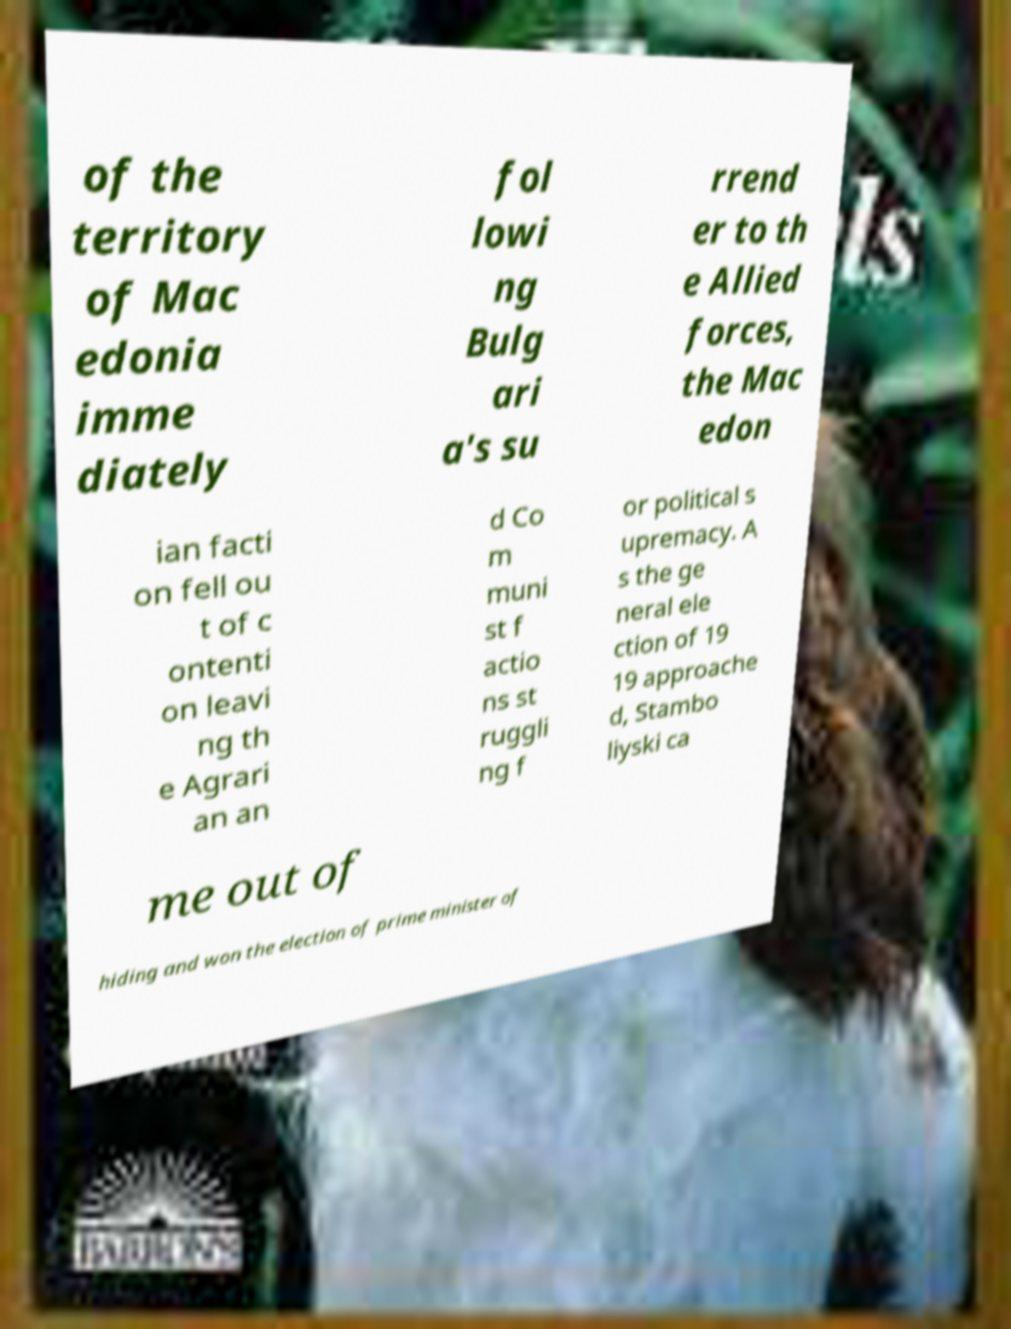There's text embedded in this image that I need extracted. Can you transcribe it verbatim? of the territory of Mac edonia imme diately fol lowi ng Bulg ari a's su rrend er to th e Allied forces, the Mac edon ian facti on fell ou t of c ontenti on leavi ng th e Agrari an an d Co m muni st f actio ns st ruggli ng f or political s upremacy. A s the ge neral ele ction of 19 19 approache d, Stambo liyski ca me out of hiding and won the election of prime minister of 